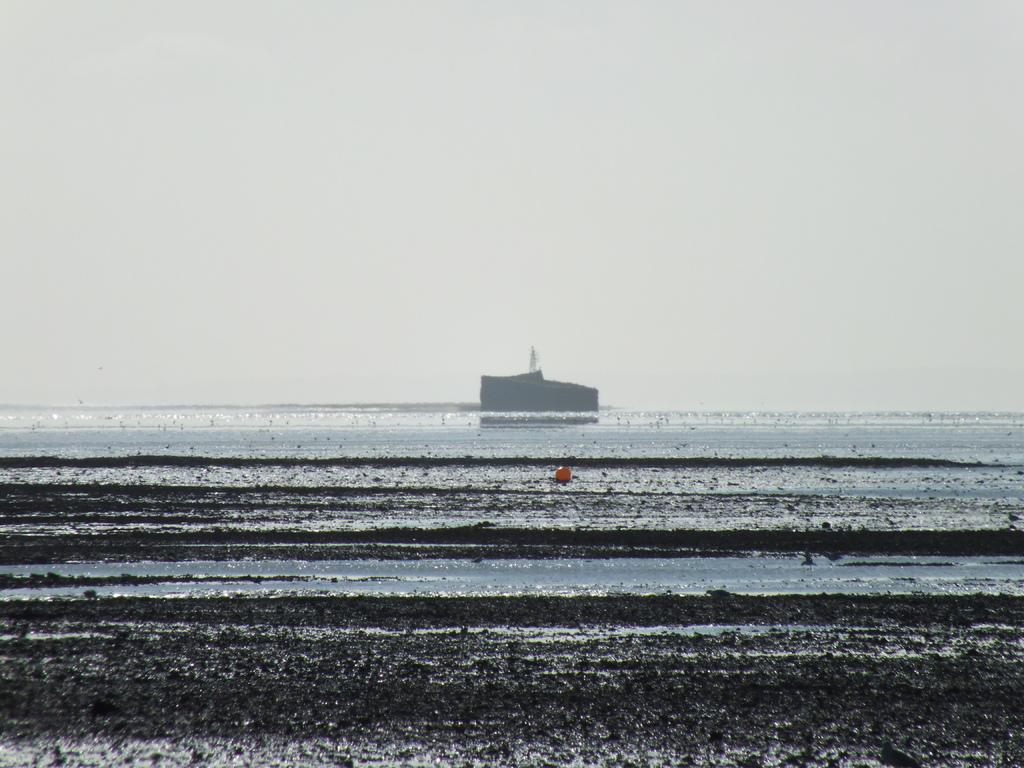What type of water is present at the bottom of the image? There is water at the bottom of the image, and it appears to be an ocean. What other objects can be seen in the background of the image? There is a boat and a ship in the background of the image. What is visible at the top of the image? The sky is visible at the top of the image. Where is the quicksand located in the image? There is no quicksand present in the image. What part of the body is visible in the image? There are no body parts visible in the image. 